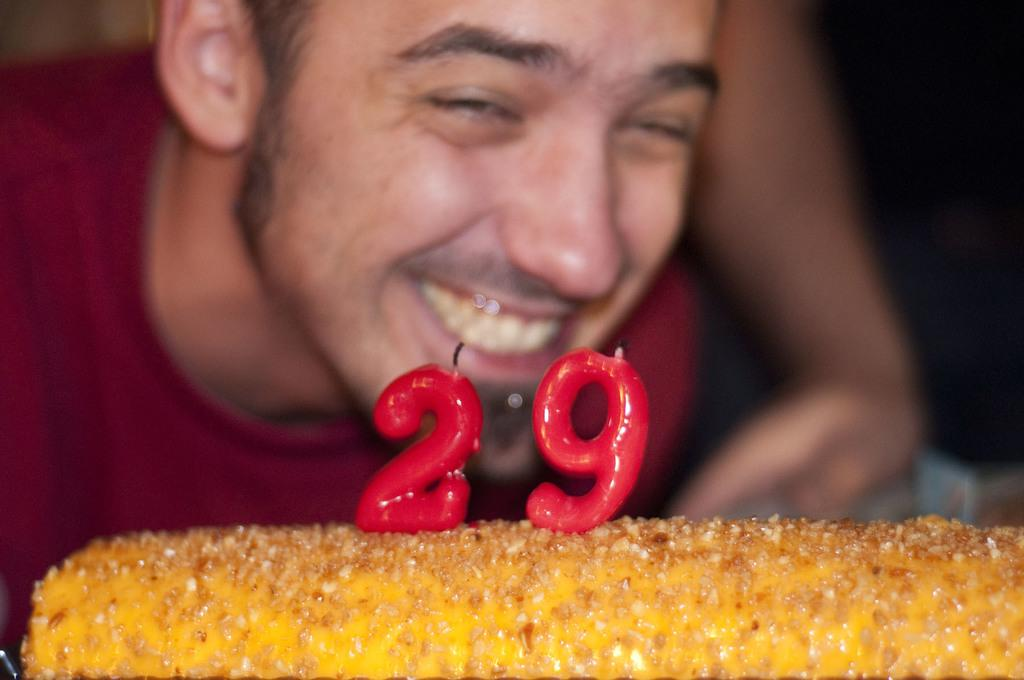Who is present in the image? There is a man in the image. Where is the man positioned in the image? The man is standing in the back. What is the man wearing in the image? The man is wearing a maroon t-shirt. What is the main food item in the image? There is a cake in the image. What is on top of the cake? The cake has candles on it. What type of knife is being used to cut the cake in the image? There is no knife present in the image, and the cake has not been cut. 